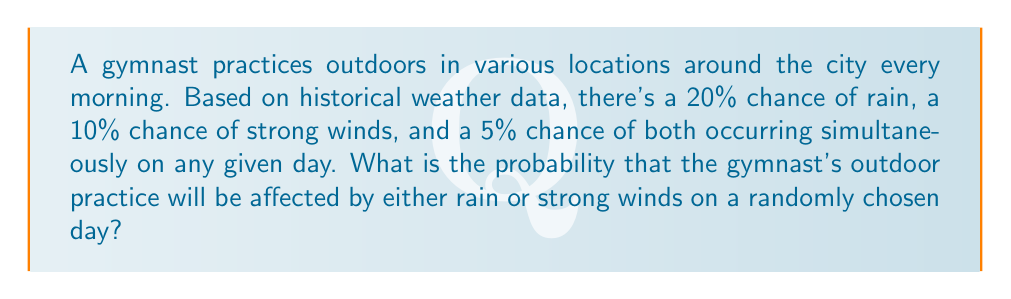Solve this math problem. Let's approach this step-by-step using the addition rule of probability:

1) Let $R$ be the event of rain occurring, and $W$ be the event of strong winds occurring.

2) We're given:
   $P(R) = 0.20$
   $P(W) = 0.10$
   $P(R \text{ and } W) = 0.05$

3) We want to find $P(R \text{ or } W)$, which is the probability of either rain or strong winds (or both) occurring.

4) The addition rule of probability states:
   $P(R \text{ or } W) = P(R) + P(W) - P(R \text{ and } W)$

5) Substituting the given probabilities:
   $P(R \text{ or } W) = 0.20 + 0.10 - 0.05$

6) Calculating:
   $P(R \text{ or } W) = 0.25$

7) Converting to a percentage:
   $0.25 \times 100\% = 25\%$

Therefore, there's a 25% chance that the gymnast's outdoor practice will be affected by either rain or strong winds on a randomly chosen day.
Answer: 25% 